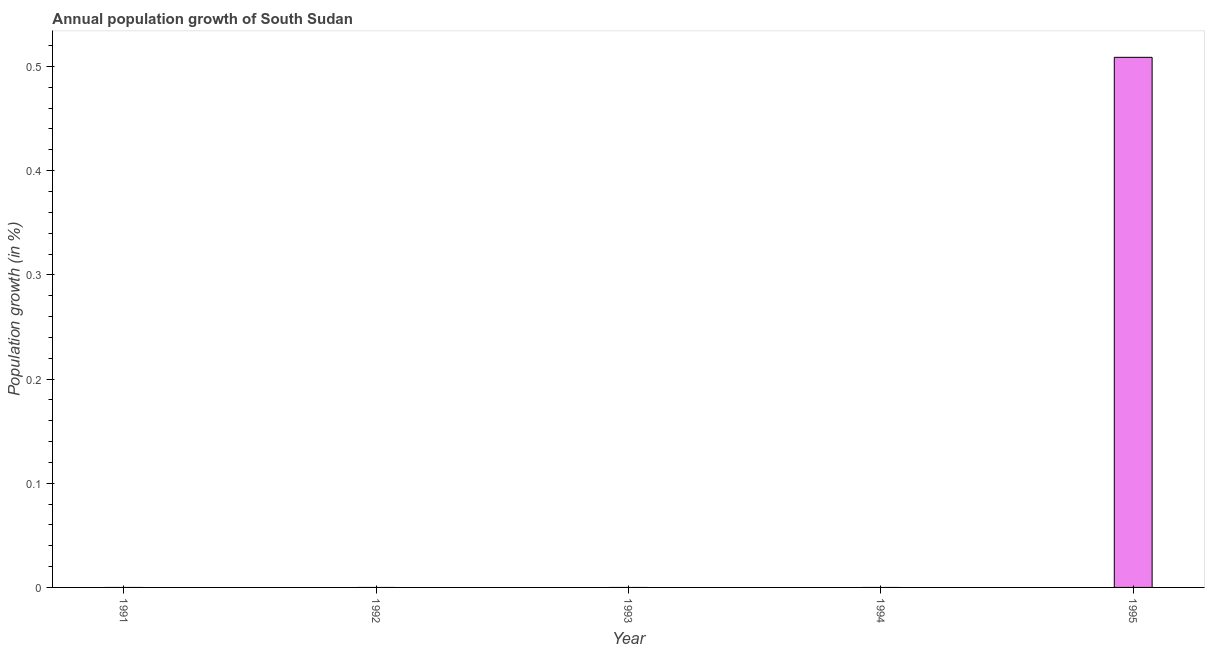Does the graph contain any zero values?
Give a very brief answer. Yes. Does the graph contain grids?
Offer a terse response. No. What is the title of the graph?
Keep it short and to the point. Annual population growth of South Sudan. What is the label or title of the Y-axis?
Your answer should be compact. Population growth (in %). What is the population growth in 1992?
Provide a succinct answer. 0. Across all years, what is the maximum population growth?
Provide a succinct answer. 0.51. Across all years, what is the minimum population growth?
Your answer should be compact. 0. What is the sum of the population growth?
Provide a short and direct response. 0.51. What is the average population growth per year?
Make the answer very short. 0.1. In how many years, is the population growth greater than 0.34 %?
Give a very brief answer. 1. What is the difference between the highest and the lowest population growth?
Your answer should be very brief. 0.51. In how many years, is the population growth greater than the average population growth taken over all years?
Your answer should be compact. 1. How many bars are there?
Keep it short and to the point. 1. Are the values on the major ticks of Y-axis written in scientific E-notation?
Your response must be concise. No. What is the Population growth (in %) of 1991?
Offer a very short reply. 0. What is the Population growth (in %) of 1992?
Offer a very short reply. 0. What is the Population growth (in %) in 1993?
Your answer should be compact. 0. What is the Population growth (in %) of 1995?
Give a very brief answer. 0.51. 